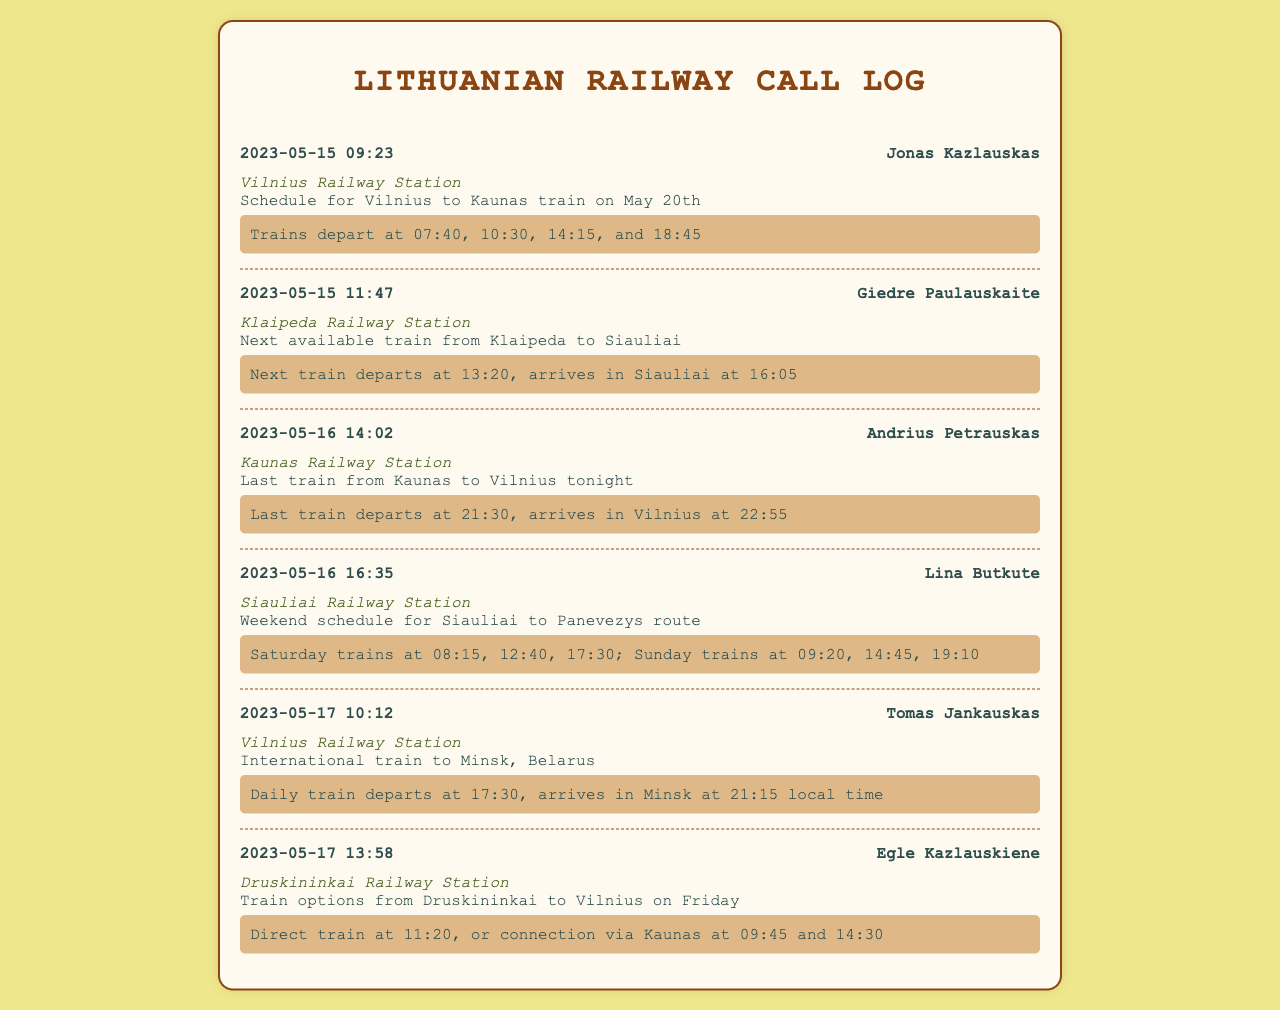What is the date of the first inquiry? The first inquiry was made on May 15, 2023 at 09:23.
Answer: May 15, 2023 Who made the inquiry about the weekend schedule from Siauliai to Panevezys? Lina Butkute is the person who inquired about the weekend schedule for that route.
Answer: Lina Butkute What was the departure time of the last train from Kaunas to Vilnius? The last train departs at 21:30 according to the inquiry log from Kaunas Railway Station.
Answer: 21:30 How many trains are scheduled from Siauliai to Panevezys on Saturday? There are three trains scheduled on Saturday according to the call log entry.
Answer: 3 What is the arrival time of the international train to Minsk? The train arrives in Minsk at 21:15 local time, according to the response for the inquiry from Vilnius Railway Station.
Answer: 21:15 Who inquired about the next available train from Klaipeda to Siauliai? Giedre Paulauskaite made the inquiry regarding the next available train from Klaipeda to Siauliai.
Answer: Giedre Paulauskaite What are the times of the trains departing from Vilnius to Kaunas on May 20th? Trains depart at 07:40, 10:30, 14:15, and 18:45 according to the inquiry from Vilnius Railway Station.
Answer: 07:40, 10:30, 14:15, 18:45 What is the time for the direct train from Druskininkai to Vilnius? The direct train from Druskininkai to Vilnius departs at 11:20.
Answer: 11:20 